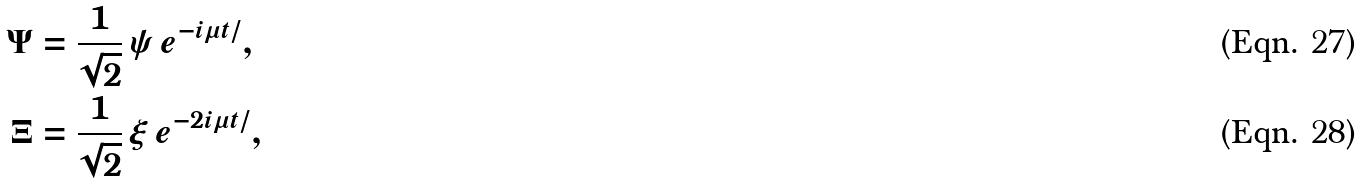<formula> <loc_0><loc_0><loc_500><loc_500>\Psi & = \frac { 1 } { \sqrt { 2 } } \, \psi \, e ^ { - i \mu t / } , \\ \Xi & = \frac { 1 } { \sqrt { 2 } } \, \xi \, e ^ { - 2 i \mu t / } ,</formula> 